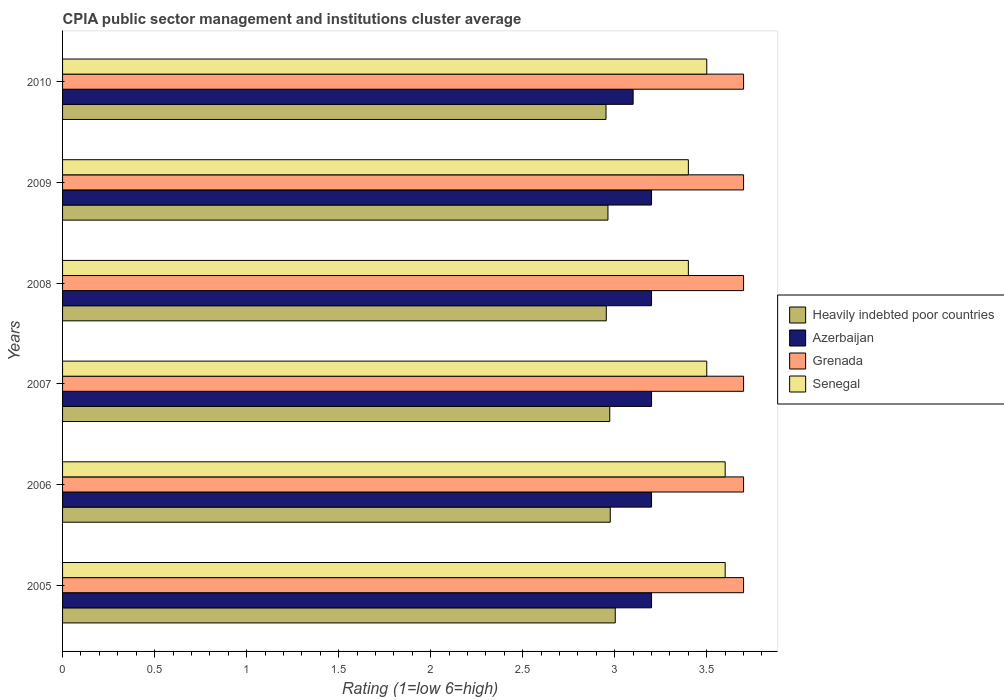How many different coloured bars are there?
Your answer should be very brief. 4. How many groups of bars are there?
Make the answer very short. 6. How many bars are there on the 2nd tick from the top?
Your answer should be compact. 4. How many bars are there on the 1st tick from the bottom?
Provide a short and direct response. 4. What is the label of the 6th group of bars from the top?
Your answer should be very brief. 2005. In how many cases, is the number of bars for a given year not equal to the number of legend labels?
Ensure brevity in your answer.  0. Across all years, what is the maximum CPIA rating in Heavily indebted poor countries?
Offer a terse response. 3. Across all years, what is the minimum CPIA rating in Heavily indebted poor countries?
Ensure brevity in your answer.  2.95. What is the total CPIA rating in Heavily indebted poor countries in the graph?
Give a very brief answer. 17.82. What is the difference between the CPIA rating in Heavily indebted poor countries in 2008 and that in 2009?
Your answer should be very brief. -0.01. What is the difference between the CPIA rating in Azerbaijan in 2006 and the CPIA rating in Heavily indebted poor countries in 2009?
Make the answer very short. 0.24. What is the average CPIA rating in Azerbaijan per year?
Give a very brief answer. 3.18. In the year 2005, what is the difference between the CPIA rating in Azerbaijan and CPIA rating in Heavily indebted poor countries?
Your response must be concise. 0.2. What is the ratio of the CPIA rating in Azerbaijan in 2006 to that in 2008?
Offer a very short reply. 1. What is the difference between the highest and the second highest CPIA rating in Heavily indebted poor countries?
Provide a short and direct response. 0.03. What is the difference between the highest and the lowest CPIA rating in Azerbaijan?
Keep it short and to the point. 0.1. In how many years, is the CPIA rating in Grenada greater than the average CPIA rating in Grenada taken over all years?
Give a very brief answer. 6. What does the 1st bar from the top in 2007 represents?
Give a very brief answer. Senegal. What does the 1st bar from the bottom in 2009 represents?
Ensure brevity in your answer.  Heavily indebted poor countries. Is it the case that in every year, the sum of the CPIA rating in Heavily indebted poor countries and CPIA rating in Senegal is greater than the CPIA rating in Grenada?
Your answer should be compact. Yes. How many bars are there?
Give a very brief answer. 24. What is the difference between two consecutive major ticks on the X-axis?
Make the answer very short. 0.5. Where does the legend appear in the graph?
Keep it short and to the point. Center right. How many legend labels are there?
Make the answer very short. 4. How are the legend labels stacked?
Ensure brevity in your answer.  Vertical. What is the title of the graph?
Give a very brief answer. CPIA public sector management and institutions cluster average. What is the label or title of the X-axis?
Keep it short and to the point. Rating (1=low 6=high). What is the label or title of the Y-axis?
Give a very brief answer. Years. What is the Rating (1=low 6=high) of Heavily indebted poor countries in 2005?
Give a very brief answer. 3. What is the Rating (1=low 6=high) in Azerbaijan in 2005?
Offer a terse response. 3.2. What is the Rating (1=low 6=high) in Senegal in 2005?
Provide a succinct answer. 3.6. What is the Rating (1=low 6=high) of Heavily indebted poor countries in 2006?
Your answer should be very brief. 2.98. What is the Rating (1=low 6=high) in Heavily indebted poor countries in 2007?
Ensure brevity in your answer.  2.97. What is the Rating (1=low 6=high) in Senegal in 2007?
Offer a terse response. 3.5. What is the Rating (1=low 6=high) in Heavily indebted poor countries in 2008?
Offer a terse response. 2.95. What is the Rating (1=low 6=high) in Azerbaijan in 2008?
Offer a very short reply. 3.2. What is the Rating (1=low 6=high) in Grenada in 2008?
Ensure brevity in your answer.  3.7. What is the Rating (1=low 6=high) of Senegal in 2008?
Give a very brief answer. 3.4. What is the Rating (1=low 6=high) of Heavily indebted poor countries in 2009?
Provide a succinct answer. 2.96. What is the Rating (1=low 6=high) in Grenada in 2009?
Your response must be concise. 3.7. What is the Rating (1=low 6=high) of Heavily indebted poor countries in 2010?
Offer a terse response. 2.95. What is the Rating (1=low 6=high) of Azerbaijan in 2010?
Your response must be concise. 3.1. What is the Rating (1=low 6=high) in Senegal in 2010?
Your response must be concise. 3.5. Across all years, what is the maximum Rating (1=low 6=high) of Heavily indebted poor countries?
Offer a very short reply. 3. Across all years, what is the maximum Rating (1=low 6=high) in Senegal?
Keep it short and to the point. 3.6. Across all years, what is the minimum Rating (1=low 6=high) of Heavily indebted poor countries?
Your answer should be very brief. 2.95. Across all years, what is the minimum Rating (1=low 6=high) of Grenada?
Make the answer very short. 3.7. Across all years, what is the minimum Rating (1=low 6=high) of Senegal?
Your answer should be very brief. 3.4. What is the total Rating (1=low 6=high) in Heavily indebted poor countries in the graph?
Provide a succinct answer. 17.82. What is the total Rating (1=low 6=high) in Azerbaijan in the graph?
Offer a terse response. 19.1. What is the total Rating (1=low 6=high) in Grenada in the graph?
Offer a terse response. 22.2. What is the difference between the Rating (1=low 6=high) of Heavily indebted poor countries in 2005 and that in 2006?
Make the answer very short. 0.03. What is the difference between the Rating (1=low 6=high) in Heavily indebted poor countries in 2005 and that in 2007?
Offer a terse response. 0.03. What is the difference between the Rating (1=low 6=high) in Grenada in 2005 and that in 2007?
Your response must be concise. 0. What is the difference between the Rating (1=low 6=high) in Senegal in 2005 and that in 2007?
Offer a very short reply. 0.1. What is the difference between the Rating (1=low 6=high) in Heavily indebted poor countries in 2005 and that in 2008?
Offer a very short reply. 0.05. What is the difference between the Rating (1=low 6=high) in Heavily indebted poor countries in 2005 and that in 2009?
Your response must be concise. 0.04. What is the difference between the Rating (1=low 6=high) in Azerbaijan in 2005 and that in 2009?
Provide a succinct answer. 0. What is the difference between the Rating (1=low 6=high) of Grenada in 2005 and that in 2009?
Your answer should be compact. 0. What is the difference between the Rating (1=low 6=high) of Heavily indebted poor countries in 2005 and that in 2010?
Your response must be concise. 0.05. What is the difference between the Rating (1=low 6=high) of Grenada in 2005 and that in 2010?
Ensure brevity in your answer.  0. What is the difference between the Rating (1=low 6=high) in Senegal in 2005 and that in 2010?
Offer a terse response. 0.1. What is the difference between the Rating (1=low 6=high) in Heavily indebted poor countries in 2006 and that in 2007?
Your answer should be very brief. 0. What is the difference between the Rating (1=low 6=high) in Azerbaijan in 2006 and that in 2007?
Provide a short and direct response. 0. What is the difference between the Rating (1=low 6=high) of Grenada in 2006 and that in 2007?
Offer a very short reply. 0. What is the difference between the Rating (1=low 6=high) in Senegal in 2006 and that in 2007?
Ensure brevity in your answer.  0.1. What is the difference between the Rating (1=low 6=high) in Heavily indebted poor countries in 2006 and that in 2008?
Your answer should be compact. 0.02. What is the difference between the Rating (1=low 6=high) in Grenada in 2006 and that in 2008?
Give a very brief answer. 0. What is the difference between the Rating (1=low 6=high) in Senegal in 2006 and that in 2008?
Keep it short and to the point. 0.2. What is the difference between the Rating (1=low 6=high) in Heavily indebted poor countries in 2006 and that in 2009?
Give a very brief answer. 0.01. What is the difference between the Rating (1=low 6=high) of Azerbaijan in 2006 and that in 2009?
Keep it short and to the point. 0. What is the difference between the Rating (1=low 6=high) of Heavily indebted poor countries in 2006 and that in 2010?
Keep it short and to the point. 0.02. What is the difference between the Rating (1=low 6=high) of Grenada in 2006 and that in 2010?
Keep it short and to the point. 0. What is the difference between the Rating (1=low 6=high) of Heavily indebted poor countries in 2007 and that in 2008?
Provide a succinct answer. 0.02. What is the difference between the Rating (1=low 6=high) of Heavily indebted poor countries in 2007 and that in 2009?
Give a very brief answer. 0.01. What is the difference between the Rating (1=low 6=high) of Senegal in 2007 and that in 2009?
Provide a short and direct response. 0.1. What is the difference between the Rating (1=low 6=high) in Heavily indebted poor countries in 2007 and that in 2010?
Make the answer very short. 0.02. What is the difference between the Rating (1=low 6=high) in Grenada in 2007 and that in 2010?
Provide a succinct answer. 0. What is the difference between the Rating (1=low 6=high) of Senegal in 2007 and that in 2010?
Ensure brevity in your answer.  0. What is the difference between the Rating (1=low 6=high) in Heavily indebted poor countries in 2008 and that in 2009?
Make the answer very short. -0.01. What is the difference between the Rating (1=low 6=high) of Senegal in 2008 and that in 2009?
Ensure brevity in your answer.  0. What is the difference between the Rating (1=low 6=high) in Heavily indebted poor countries in 2008 and that in 2010?
Your response must be concise. 0. What is the difference between the Rating (1=low 6=high) in Grenada in 2008 and that in 2010?
Your answer should be very brief. 0. What is the difference between the Rating (1=low 6=high) of Heavily indebted poor countries in 2009 and that in 2010?
Offer a very short reply. 0.01. What is the difference between the Rating (1=low 6=high) of Grenada in 2009 and that in 2010?
Your answer should be very brief. 0. What is the difference between the Rating (1=low 6=high) of Senegal in 2009 and that in 2010?
Offer a terse response. -0.1. What is the difference between the Rating (1=low 6=high) in Heavily indebted poor countries in 2005 and the Rating (1=low 6=high) in Azerbaijan in 2006?
Keep it short and to the point. -0.2. What is the difference between the Rating (1=low 6=high) in Heavily indebted poor countries in 2005 and the Rating (1=low 6=high) in Grenada in 2006?
Ensure brevity in your answer.  -0.7. What is the difference between the Rating (1=low 6=high) of Heavily indebted poor countries in 2005 and the Rating (1=low 6=high) of Senegal in 2006?
Offer a terse response. -0.6. What is the difference between the Rating (1=low 6=high) in Azerbaijan in 2005 and the Rating (1=low 6=high) in Senegal in 2006?
Make the answer very short. -0.4. What is the difference between the Rating (1=low 6=high) in Heavily indebted poor countries in 2005 and the Rating (1=low 6=high) in Azerbaijan in 2007?
Your answer should be very brief. -0.2. What is the difference between the Rating (1=low 6=high) of Heavily indebted poor countries in 2005 and the Rating (1=low 6=high) of Grenada in 2007?
Your response must be concise. -0.7. What is the difference between the Rating (1=low 6=high) of Heavily indebted poor countries in 2005 and the Rating (1=low 6=high) of Senegal in 2007?
Keep it short and to the point. -0.5. What is the difference between the Rating (1=low 6=high) in Azerbaijan in 2005 and the Rating (1=low 6=high) in Grenada in 2007?
Provide a succinct answer. -0.5. What is the difference between the Rating (1=low 6=high) of Heavily indebted poor countries in 2005 and the Rating (1=low 6=high) of Azerbaijan in 2008?
Give a very brief answer. -0.2. What is the difference between the Rating (1=low 6=high) of Heavily indebted poor countries in 2005 and the Rating (1=low 6=high) of Grenada in 2008?
Make the answer very short. -0.7. What is the difference between the Rating (1=low 6=high) of Heavily indebted poor countries in 2005 and the Rating (1=low 6=high) of Senegal in 2008?
Your answer should be compact. -0.4. What is the difference between the Rating (1=low 6=high) of Grenada in 2005 and the Rating (1=low 6=high) of Senegal in 2008?
Provide a succinct answer. 0.3. What is the difference between the Rating (1=low 6=high) of Heavily indebted poor countries in 2005 and the Rating (1=low 6=high) of Azerbaijan in 2009?
Your answer should be very brief. -0.2. What is the difference between the Rating (1=low 6=high) in Heavily indebted poor countries in 2005 and the Rating (1=low 6=high) in Grenada in 2009?
Your response must be concise. -0.7. What is the difference between the Rating (1=low 6=high) of Heavily indebted poor countries in 2005 and the Rating (1=low 6=high) of Senegal in 2009?
Your answer should be very brief. -0.4. What is the difference between the Rating (1=low 6=high) in Azerbaijan in 2005 and the Rating (1=low 6=high) in Senegal in 2009?
Your answer should be compact. -0.2. What is the difference between the Rating (1=low 6=high) in Grenada in 2005 and the Rating (1=low 6=high) in Senegal in 2009?
Offer a terse response. 0.3. What is the difference between the Rating (1=low 6=high) of Heavily indebted poor countries in 2005 and the Rating (1=low 6=high) of Azerbaijan in 2010?
Provide a short and direct response. -0.1. What is the difference between the Rating (1=low 6=high) in Heavily indebted poor countries in 2005 and the Rating (1=low 6=high) in Grenada in 2010?
Give a very brief answer. -0.7. What is the difference between the Rating (1=low 6=high) of Heavily indebted poor countries in 2005 and the Rating (1=low 6=high) of Senegal in 2010?
Keep it short and to the point. -0.5. What is the difference between the Rating (1=low 6=high) in Azerbaijan in 2005 and the Rating (1=low 6=high) in Senegal in 2010?
Your response must be concise. -0.3. What is the difference between the Rating (1=low 6=high) in Heavily indebted poor countries in 2006 and the Rating (1=low 6=high) in Azerbaijan in 2007?
Keep it short and to the point. -0.22. What is the difference between the Rating (1=low 6=high) in Heavily indebted poor countries in 2006 and the Rating (1=low 6=high) in Grenada in 2007?
Ensure brevity in your answer.  -0.72. What is the difference between the Rating (1=low 6=high) of Heavily indebted poor countries in 2006 and the Rating (1=low 6=high) of Senegal in 2007?
Give a very brief answer. -0.52. What is the difference between the Rating (1=low 6=high) in Azerbaijan in 2006 and the Rating (1=low 6=high) in Senegal in 2007?
Your answer should be compact. -0.3. What is the difference between the Rating (1=low 6=high) in Grenada in 2006 and the Rating (1=low 6=high) in Senegal in 2007?
Your answer should be compact. 0.2. What is the difference between the Rating (1=low 6=high) in Heavily indebted poor countries in 2006 and the Rating (1=low 6=high) in Azerbaijan in 2008?
Make the answer very short. -0.22. What is the difference between the Rating (1=low 6=high) in Heavily indebted poor countries in 2006 and the Rating (1=low 6=high) in Grenada in 2008?
Make the answer very short. -0.72. What is the difference between the Rating (1=low 6=high) of Heavily indebted poor countries in 2006 and the Rating (1=low 6=high) of Senegal in 2008?
Keep it short and to the point. -0.42. What is the difference between the Rating (1=low 6=high) of Grenada in 2006 and the Rating (1=low 6=high) of Senegal in 2008?
Ensure brevity in your answer.  0.3. What is the difference between the Rating (1=low 6=high) of Heavily indebted poor countries in 2006 and the Rating (1=low 6=high) of Azerbaijan in 2009?
Keep it short and to the point. -0.22. What is the difference between the Rating (1=low 6=high) in Heavily indebted poor countries in 2006 and the Rating (1=low 6=high) in Grenada in 2009?
Offer a terse response. -0.72. What is the difference between the Rating (1=low 6=high) of Heavily indebted poor countries in 2006 and the Rating (1=low 6=high) of Senegal in 2009?
Keep it short and to the point. -0.42. What is the difference between the Rating (1=low 6=high) in Azerbaijan in 2006 and the Rating (1=low 6=high) in Grenada in 2009?
Offer a very short reply. -0.5. What is the difference between the Rating (1=low 6=high) in Grenada in 2006 and the Rating (1=low 6=high) in Senegal in 2009?
Your answer should be compact. 0.3. What is the difference between the Rating (1=low 6=high) of Heavily indebted poor countries in 2006 and the Rating (1=low 6=high) of Azerbaijan in 2010?
Your answer should be very brief. -0.12. What is the difference between the Rating (1=low 6=high) of Heavily indebted poor countries in 2006 and the Rating (1=low 6=high) of Grenada in 2010?
Make the answer very short. -0.72. What is the difference between the Rating (1=low 6=high) in Heavily indebted poor countries in 2006 and the Rating (1=low 6=high) in Senegal in 2010?
Provide a short and direct response. -0.52. What is the difference between the Rating (1=low 6=high) of Grenada in 2006 and the Rating (1=low 6=high) of Senegal in 2010?
Make the answer very short. 0.2. What is the difference between the Rating (1=low 6=high) of Heavily indebted poor countries in 2007 and the Rating (1=low 6=high) of Azerbaijan in 2008?
Your answer should be compact. -0.23. What is the difference between the Rating (1=low 6=high) of Heavily indebted poor countries in 2007 and the Rating (1=low 6=high) of Grenada in 2008?
Offer a very short reply. -0.73. What is the difference between the Rating (1=low 6=high) of Heavily indebted poor countries in 2007 and the Rating (1=low 6=high) of Senegal in 2008?
Make the answer very short. -0.43. What is the difference between the Rating (1=low 6=high) in Azerbaijan in 2007 and the Rating (1=low 6=high) in Grenada in 2008?
Give a very brief answer. -0.5. What is the difference between the Rating (1=low 6=high) of Heavily indebted poor countries in 2007 and the Rating (1=low 6=high) of Azerbaijan in 2009?
Offer a very short reply. -0.23. What is the difference between the Rating (1=low 6=high) of Heavily indebted poor countries in 2007 and the Rating (1=low 6=high) of Grenada in 2009?
Ensure brevity in your answer.  -0.73. What is the difference between the Rating (1=low 6=high) of Heavily indebted poor countries in 2007 and the Rating (1=low 6=high) of Senegal in 2009?
Ensure brevity in your answer.  -0.43. What is the difference between the Rating (1=low 6=high) of Grenada in 2007 and the Rating (1=low 6=high) of Senegal in 2009?
Ensure brevity in your answer.  0.3. What is the difference between the Rating (1=low 6=high) in Heavily indebted poor countries in 2007 and the Rating (1=low 6=high) in Azerbaijan in 2010?
Your answer should be very brief. -0.13. What is the difference between the Rating (1=low 6=high) of Heavily indebted poor countries in 2007 and the Rating (1=low 6=high) of Grenada in 2010?
Offer a very short reply. -0.73. What is the difference between the Rating (1=low 6=high) of Heavily indebted poor countries in 2007 and the Rating (1=low 6=high) of Senegal in 2010?
Give a very brief answer. -0.53. What is the difference between the Rating (1=low 6=high) in Azerbaijan in 2007 and the Rating (1=low 6=high) in Senegal in 2010?
Your answer should be compact. -0.3. What is the difference between the Rating (1=low 6=high) in Heavily indebted poor countries in 2008 and the Rating (1=low 6=high) in Azerbaijan in 2009?
Offer a terse response. -0.25. What is the difference between the Rating (1=low 6=high) of Heavily indebted poor countries in 2008 and the Rating (1=low 6=high) of Grenada in 2009?
Make the answer very short. -0.75. What is the difference between the Rating (1=low 6=high) in Heavily indebted poor countries in 2008 and the Rating (1=low 6=high) in Senegal in 2009?
Keep it short and to the point. -0.45. What is the difference between the Rating (1=low 6=high) in Grenada in 2008 and the Rating (1=low 6=high) in Senegal in 2009?
Your answer should be compact. 0.3. What is the difference between the Rating (1=low 6=high) of Heavily indebted poor countries in 2008 and the Rating (1=low 6=high) of Azerbaijan in 2010?
Make the answer very short. -0.15. What is the difference between the Rating (1=low 6=high) of Heavily indebted poor countries in 2008 and the Rating (1=low 6=high) of Grenada in 2010?
Your answer should be very brief. -0.75. What is the difference between the Rating (1=low 6=high) of Heavily indebted poor countries in 2008 and the Rating (1=low 6=high) of Senegal in 2010?
Give a very brief answer. -0.55. What is the difference between the Rating (1=low 6=high) in Azerbaijan in 2008 and the Rating (1=low 6=high) in Senegal in 2010?
Make the answer very short. -0.3. What is the difference between the Rating (1=low 6=high) of Heavily indebted poor countries in 2009 and the Rating (1=low 6=high) of Azerbaijan in 2010?
Provide a short and direct response. -0.14. What is the difference between the Rating (1=low 6=high) of Heavily indebted poor countries in 2009 and the Rating (1=low 6=high) of Grenada in 2010?
Keep it short and to the point. -0.74. What is the difference between the Rating (1=low 6=high) in Heavily indebted poor countries in 2009 and the Rating (1=low 6=high) in Senegal in 2010?
Provide a succinct answer. -0.54. What is the difference between the Rating (1=low 6=high) of Azerbaijan in 2009 and the Rating (1=low 6=high) of Senegal in 2010?
Your answer should be compact. -0.3. What is the average Rating (1=low 6=high) of Heavily indebted poor countries per year?
Your answer should be compact. 2.97. What is the average Rating (1=low 6=high) in Azerbaijan per year?
Your response must be concise. 3.18. What is the average Rating (1=low 6=high) in Senegal per year?
Your answer should be compact. 3.5. In the year 2005, what is the difference between the Rating (1=low 6=high) in Heavily indebted poor countries and Rating (1=low 6=high) in Azerbaijan?
Offer a very short reply. -0.2. In the year 2005, what is the difference between the Rating (1=low 6=high) in Heavily indebted poor countries and Rating (1=low 6=high) in Grenada?
Keep it short and to the point. -0.7. In the year 2005, what is the difference between the Rating (1=low 6=high) of Heavily indebted poor countries and Rating (1=low 6=high) of Senegal?
Your answer should be compact. -0.6. In the year 2006, what is the difference between the Rating (1=low 6=high) of Heavily indebted poor countries and Rating (1=low 6=high) of Azerbaijan?
Provide a succinct answer. -0.22. In the year 2006, what is the difference between the Rating (1=low 6=high) of Heavily indebted poor countries and Rating (1=low 6=high) of Grenada?
Your answer should be compact. -0.72. In the year 2006, what is the difference between the Rating (1=low 6=high) of Heavily indebted poor countries and Rating (1=low 6=high) of Senegal?
Keep it short and to the point. -0.62. In the year 2007, what is the difference between the Rating (1=low 6=high) of Heavily indebted poor countries and Rating (1=low 6=high) of Azerbaijan?
Keep it short and to the point. -0.23. In the year 2007, what is the difference between the Rating (1=low 6=high) of Heavily indebted poor countries and Rating (1=low 6=high) of Grenada?
Provide a succinct answer. -0.73. In the year 2007, what is the difference between the Rating (1=low 6=high) of Heavily indebted poor countries and Rating (1=low 6=high) of Senegal?
Make the answer very short. -0.53. In the year 2007, what is the difference between the Rating (1=low 6=high) in Grenada and Rating (1=low 6=high) in Senegal?
Offer a terse response. 0.2. In the year 2008, what is the difference between the Rating (1=low 6=high) of Heavily indebted poor countries and Rating (1=low 6=high) of Azerbaijan?
Your response must be concise. -0.25. In the year 2008, what is the difference between the Rating (1=low 6=high) in Heavily indebted poor countries and Rating (1=low 6=high) in Grenada?
Offer a very short reply. -0.75. In the year 2008, what is the difference between the Rating (1=low 6=high) in Heavily indebted poor countries and Rating (1=low 6=high) in Senegal?
Your answer should be very brief. -0.45. In the year 2008, what is the difference between the Rating (1=low 6=high) of Azerbaijan and Rating (1=low 6=high) of Grenada?
Provide a short and direct response. -0.5. In the year 2008, what is the difference between the Rating (1=low 6=high) in Azerbaijan and Rating (1=low 6=high) in Senegal?
Ensure brevity in your answer.  -0.2. In the year 2008, what is the difference between the Rating (1=low 6=high) of Grenada and Rating (1=low 6=high) of Senegal?
Provide a short and direct response. 0.3. In the year 2009, what is the difference between the Rating (1=low 6=high) of Heavily indebted poor countries and Rating (1=low 6=high) of Azerbaijan?
Your answer should be compact. -0.24. In the year 2009, what is the difference between the Rating (1=low 6=high) in Heavily indebted poor countries and Rating (1=low 6=high) in Grenada?
Ensure brevity in your answer.  -0.74. In the year 2009, what is the difference between the Rating (1=low 6=high) of Heavily indebted poor countries and Rating (1=low 6=high) of Senegal?
Make the answer very short. -0.44. In the year 2009, what is the difference between the Rating (1=low 6=high) of Grenada and Rating (1=low 6=high) of Senegal?
Provide a succinct answer. 0.3. In the year 2010, what is the difference between the Rating (1=low 6=high) of Heavily indebted poor countries and Rating (1=low 6=high) of Azerbaijan?
Provide a succinct answer. -0.15. In the year 2010, what is the difference between the Rating (1=low 6=high) of Heavily indebted poor countries and Rating (1=low 6=high) of Grenada?
Provide a succinct answer. -0.75. In the year 2010, what is the difference between the Rating (1=low 6=high) in Heavily indebted poor countries and Rating (1=low 6=high) in Senegal?
Your response must be concise. -0.55. In the year 2010, what is the difference between the Rating (1=low 6=high) in Azerbaijan and Rating (1=low 6=high) in Grenada?
Ensure brevity in your answer.  -0.6. In the year 2010, what is the difference between the Rating (1=low 6=high) in Azerbaijan and Rating (1=low 6=high) in Senegal?
Provide a short and direct response. -0.4. What is the ratio of the Rating (1=low 6=high) of Heavily indebted poor countries in 2005 to that in 2006?
Make the answer very short. 1.01. What is the ratio of the Rating (1=low 6=high) in Heavily indebted poor countries in 2005 to that in 2007?
Your answer should be compact. 1.01. What is the ratio of the Rating (1=low 6=high) of Senegal in 2005 to that in 2007?
Your answer should be very brief. 1.03. What is the ratio of the Rating (1=low 6=high) in Heavily indebted poor countries in 2005 to that in 2008?
Provide a short and direct response. 1.02. What is the ratio of the Rating (1=low 6=high) in Grenada in 2005 to that in 2008?
Your answer should be very brief. 1. What is the ratio of the Rating (1=low 6=high) of Senegal in 2005 to that in 2008?
Offer a very short reply. 1.06. What is the ratio of the Rating (1=low 6=high) in Heavily indebted poor countries in 2005 to that in 2009?
Ensure brevity in your answer.  1.01. What is the ratio of the Rating (1=low 6=high) in Azerbaijan in 2005 to that in 2009?
Provide a short and direct response. 1. What is the ratio of the Rating (1=low 6=high) in Senegal in 2005 to that in 2009?
Offer a very short reply. 1.06. What is the ratio of the Rating (1=low 6=high) of Azerbaijan in 2005 to that in 2010?
Ensure brevity in your answer.  1.03. What is the ratio of the Rating (1=low 6=high) in Senegal in 2005 to that in 2010?
Offer a terse response. 1.03. What is the ratio of the Rating (1=low 6=high) in Heavily indebted poor countries in 2006 to that in 2007?
Your answer should be compact. 1. What is the ratio of the Rating (1=low 6=high) in Azerbaijan in 2006 to that in 2007?
Make the answer very short. 1. What is the ratio of the Rating (1=low 6=high) of Grenada in 2006 to that in 2007?
Keep it short and to the point. 1. What is the ratio of the Rating (1=low 6=high) in Senegal in 2006 to that in 2007?
Make the answer very short. 1.03. What is the ratio of the Rating (1=low 6=high) of Heavily indebted poor countries in 2006 to that in 2008?
Provide a short and direct response. 1.01. What is the ratio of the Rating (1=low 6=high) in Azerbaijan in 2006 to that in 2008?
Offer a terse response. 1. What is the ratio of the Rating (1=low 6=high) in Senegal in 2006 to that in 2008?
Provide a succinct answer. 1.06. What is the ratio of the Rating (1=low 6=high) in Senegal in 2006 to that in 2009?
Your answer should be very brief. 1.06. What is the ratio of the Rating (1=low 6=high) of Heavily indebted poor countries in 2006 to that in 2010?
Your answer should be compact. 1.01. What is the ratio of the Rating (1=low 6=high) of Azerbaijan in 2006 to that in 2010?
Provide a succinct answer. 1.03. What is the ratio of the Rating (1=low 6=high) of Grenada in 2006 to that in 2010?
Your answer should be compact. 1. What is the ratio of the Rating (1=low 6=high) in Senegal in 2006 to that in 2010?
Offer a terse response. 1.03. What is the ratio of the Rating (1=low 6=high) of Heavily indebted poor countries in 2007 to that in 2008?
Offer a very short reply. 1.01. What is the ratio of the Rating (1=low 6=high) in Senegal in 2007 to that in 2008?
Your response must be concise. 1.03. What is the ratio of the Rating (1=low 6=high) in Heavily indebted poor countries in 2007 to that in 2009?
Ensure brevity in your answer.  1. What is the ratio of the Rating (1=low 6=high) of Senegal in 2007 to that in 2009?
Make the answer very short. 1.03. What is the ratio of the Rating (1=low 6=high) of Azerbaijan in 2007 to that in 2010?
Offer a very short reply. 1.03. What is the ratio of the Rating (1=low 6=high) of Grenada in 2007 to that in 2010?
Offer a terse response. 1. What is the ratio of the Rating (1=low 6=high) in Senegal in 2007 to that in 2010?
Offer a very short reply. 1. What is the ratio of the Rating (1=low 6=high) in Heavily indebted poor countries in 2008 to that in 2009?
Offer a terse response. 1. What is the ratio of the Rating (1=low 6=high) in Azerbaijan in 2008 to that in 2009?
Make the answer very short. 1. What is the ratio of the Rating (1=low 6=high) of Grenada in 2008 to that in 2009?
Ensure brevity in your answer.  1. What is the ratio of the Rating (1=low 6=high) of Senegal in 2008 to that in 2009?
Provide a succinct answer. 1. What is the ratio of the Rating (1=low 6=high) in Heavily indebted poor countries in 2008 to that in 2010?
Your response must be concise. 1. What is the ratio of the Rating (1=low 6=high) of Azerbaijan in 2008 to that in 2010?
Keep it short and to the point. 1.03. What is the ratio of the Rating (1=low 6=high) of Grenada in 2008 to that in 2010?
Keep it short and to the point. 1. What is the ratio of the Rating (1=low 6=high) in Senegal in 2008 to that in 2010?
Your response must be concise. 0.97. What is the ratio of the Rating (1=low 6=high) of Azerbaijan in 2009 to that in 2010?
Provide a short and direct response. 1.03. What is the ratio of the Rating (1=low 6=high) in Grenada in 2009 to that in 2010?
Offer a terse response. 1. What is the ratio of the Rating (1=low 6=high) in Senegal in 2009 to that in 2010?
Provide a short and direct response. 0.97. What is the difference between the highest and the second highest Rating (1=low 6=high) of Heavily indebted poor countries?
Provide a short and direct response. 0.03. What is the difference between the highest and the second highest Rating (1=low 6=high) in Senegal?
Give a very brief answer. 0. What is the difference between the highest and the lowest Rating (1=low 6=high) in Heavily indebted poor countries?
Keep it short and to the point. 0.05. 